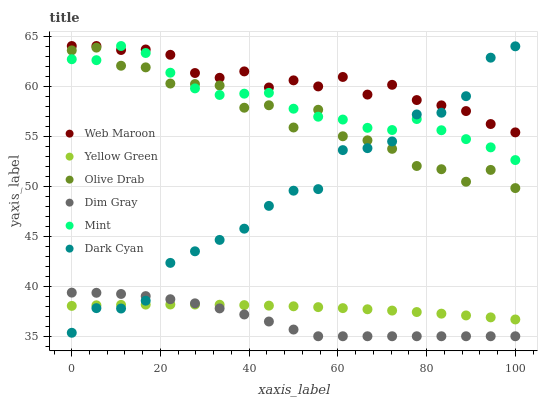Does Dim Gray have the minimum area under the curve?
Answer yes or no. Yes. Does Web Maroon have the maximum area under the curve?
Answer yes or no. Yes. Does Yellow Green have the minimum area under the curve?
Answer yes or no. No. Does Yellow Green have the maximum area under the curve?
Answer yes or no. No. Is Yellow Green the smoothest?
Answer yes or no. Yes. Is Olive Drab the roughest?
Answer yes or no. Yes. Is Web Maroon the smoothest?
Answer yes or no. No. Is Web Maroon the roughest?
Answer yes or no. No. Does Dim Gray have the lowest value?
Answer yes or no. Yes. Does Yellow Green have the lowest value?
Answer yes or no. No. Does Mint have the highest value?
Answer yes or no. Yes. Does Yellow Green have the highest value?
Answer yes or no. No. Is Dim Gray less than Mint?
Answer yes or no. Yes. Is Mint greater than Yellow Green?
Answer yes or no. Yes. Does Web Maroon intersect Dark Cyan?
Answer yes or no. Yes. Is Web Maroon less than Dark Cyan?
Answer yes or no. No. Is Web Maroon greater than Dark Cyan?
Answer yes or no. No. Does Dim Gray intersect Mint?
Answer yes or no. No. 